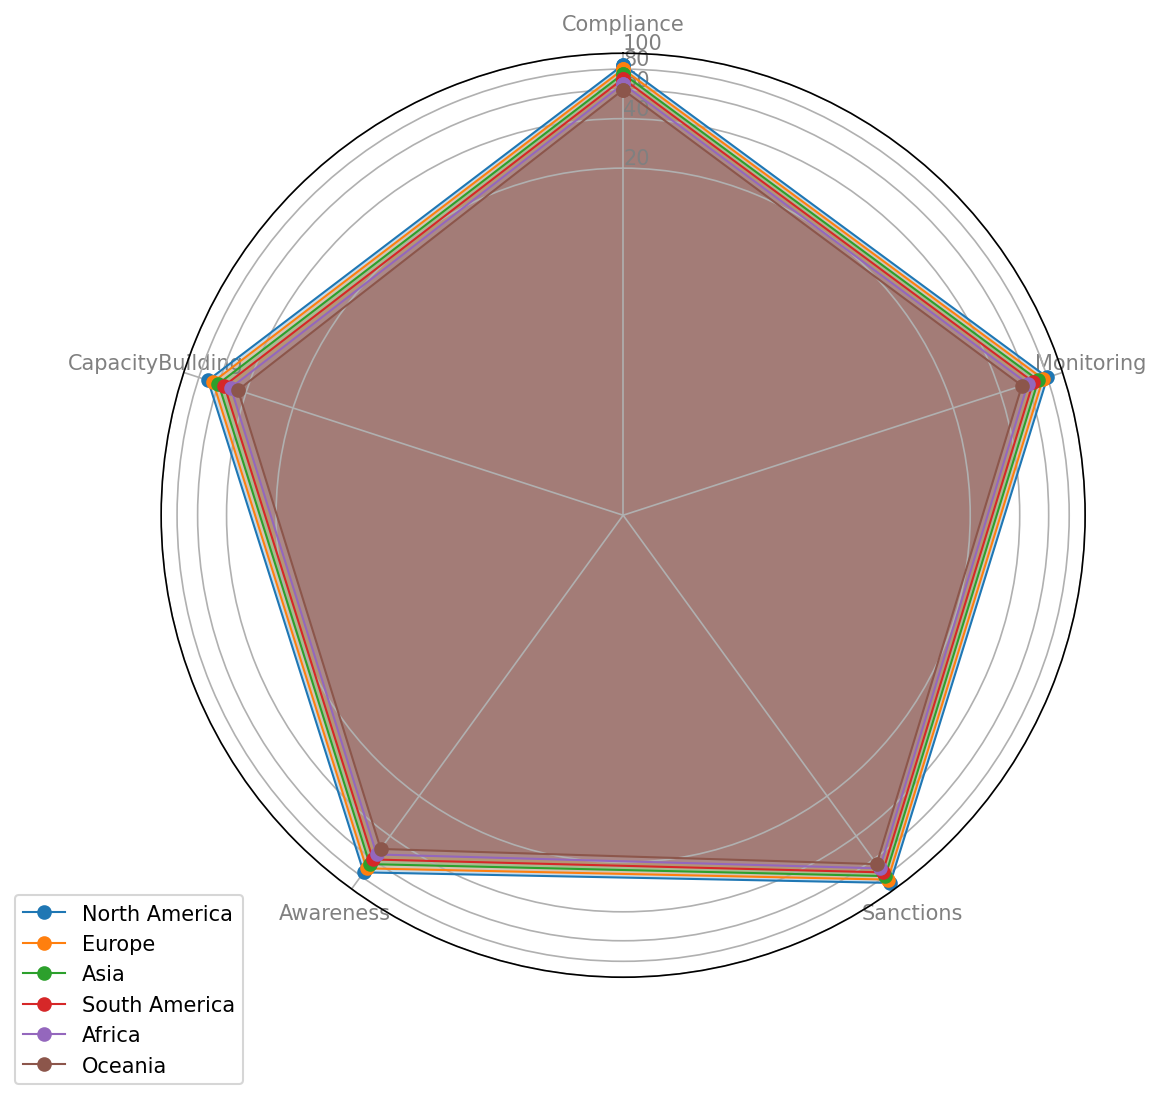Which region has the lowest capacity building index? From the chart, Oceania has the smallest value for the Capacity Building attribute.
Answer: Oceania By how many points does North America exceed Europe in compliance? North America has a compliance score of 85 and Europe has a score of 80. Subtract 80 from 85.
Answer: 5 points Which region shows the highest awareness index? The plot indicates that North America has the highest value in the Awareness attribute.
Answer: North America What is the average monitoring index across all regions? Sum all the monitoring indices: (80 + 75 + 70 + 65 + 60 + 55) = 405. Divide by the number of regions, which is 6.
Answer: 67.5 In which category does Africa have the highest value? Africa's highest value is in the Compliance category, according to the radar chart.
Answer: Compliance Compare the sanctions index of South America and Oceania. Which one is higher and by how much? South America has a sanctions index of 75, and Oceania has a score of 65. Subtract Oceania's score from South America's.
Answer: South America by 10 points What is the median value of the Compliance index across all regions? Sort the compliance values: (60, 65, 70, 75, 80, 85). The median is the average of the middle two values, (70+75)/2.
Answer: 72.5 Which region has the highest spread between its compliance and capacity building indices? Calculate spreads: North America = 85-70=15, Europe = 80-65=15, Asia = 75-60=15, South America = 70-55=15, Africa = 65-50=15, Oceania = 60-45=15. All regions have the same spread.
Answer: All regions Which region has the lowest average score across all categories? Calculate the average for each region and find the lowest: Oceania (60+55+65+50+45)/5=55, which is the lowest among the regions.
Answer: Oceania How much higher is North America's sanctions index compared to Asia's? North America's sanctions index is 90 and Asia's is 80. Subtract Asia's score from North America's.
Answer: 10 points 